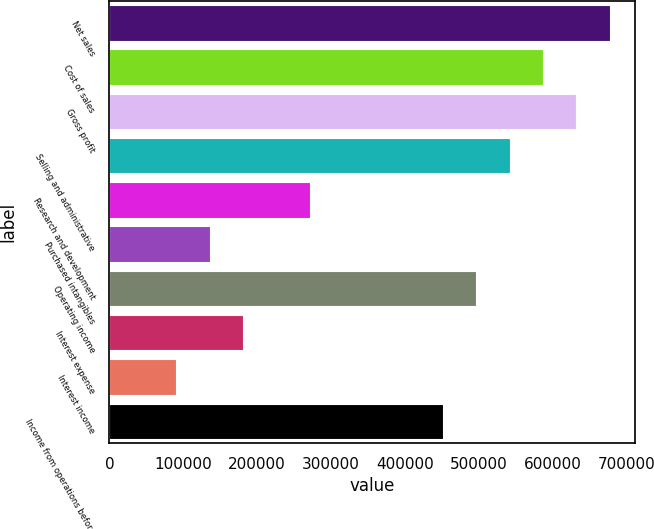<chart> <loc_0><loc_0><loc_500><loc_500><bar_chart><fcel>Net sales<fcel>Cost of sales<fcel>Gross profit<fcel>Selling and administrative<fcel>Research and development<fcel>Purchased intangibles<fcel>Operating income<fcel>Interest expense<fcel>Interest income<fcel>Income from operations before<nl><fcel>677197<fcel>586904<fcel>632051<fcel>541758<fcel>270879<fcel>135440<fcel>496611<fcel>180587<fcel>90293.9<fcel>451465<nl></chart> 